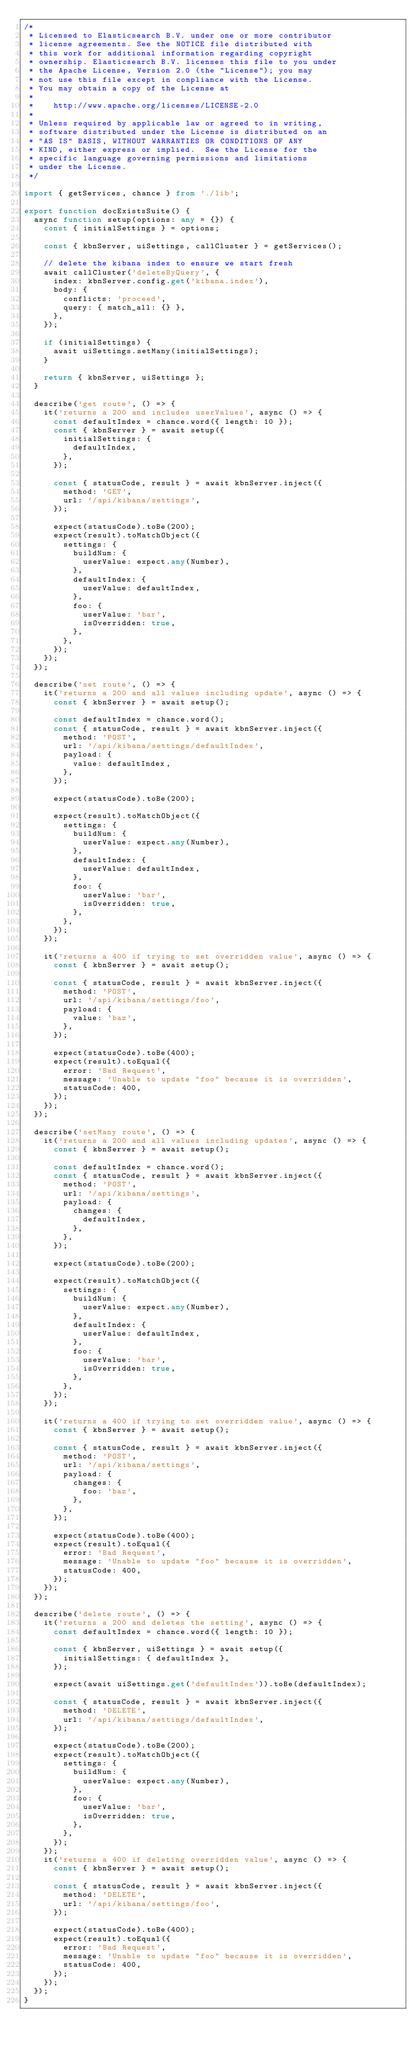Convert code to text. <code><loc_0><loc_0><loc_500><loc_500><_TypeScript_>/*
 * Licensed to Elasticsearch B.V. under one or more contributor
 * license agreements. See the NOTICE file distributed with
 * this work for additional information regarding copyright
 * ownership. Elasticsearch B.V. licenses this file to you under
 * the Apache License, Version 2.0 (the "License"); you may
 * not use this file except in compliance with the License.
 * You may obtain a copy of the License at
 *
 *    http://www.apache.org/licenses/LICENSE-2.0
 *
 * Unless required by applicable law or agreed to in writing,
 * software distributed under the License is distributed on an
 * "AS IS" BASIS, WITHOUT WARRANTIES OR CONDITIONS OF ANY
 * KIND, either express or implied.  See the License for the
 * specific language governing permissions and limitations
 * under the License.
 */

import { getServices, chance } from './lib';

export function docExistsSuite() {
  async function setup(options: any = {}) {
    const { initialSettings } = options;

    const { kbnServer, uiSettings, callCluster } = getServices();

    // delete the kibana index to ensure we start fresh
    await callCluster('deleteByQuery', {
      index: kbnServer.config.get('kibana.index'),
      body: {
        conflicts: 'proceed',
        query: { match_all: {} },
      },
    });

    if (initialSettings) {
      await uiSettings.setMany(initialSettings);
    }

    return { kbnServer, uiSettings };
  }

  describe('get route', () => {
    it('returns a 200 and includes userValues', async () => {
      const defaultIndex = chance.word({ length: 10 });
      const { kbnServer } = await setup({
        initialSettings: {
          defaultIndex,
        },
      });

      const { statusCode, result } = await kbnServer.inject({
        method: 'GET',
        url: '/api/kibana/settings',
      });

      expect(statusCode).toBe(200);
      expect(result).toMatchObject({
        settings: {
          buildNum: {
            userValue: expect.any(Number),
          },
          defaultIndex: {
            userValue: defaultIndex,
          },
          foo: {
            userValue: 'bar',
            isOverridden: true,
          },
        },
      });
    });
  });

  describe('set route', () => {
    it('returns a 200 and all values including update', async () => {
      const { kbnServer } = await setup();

      const defaultIndex = chance.word();
      const { statusCode, result } = await kbnServer.inject({
        method: 'POST',
        url: '/api/kibana/settings/defaultIndex',
        payload: {
          value: defaultIndex,
        },
      });

      expect(statusCode).toBe(200);

      expect(result).toMatchObject({
        settings: {
          buildNum: {
            userValue: expect.any(Number),
          },
          defaultIndex: {
            userValue: defaultIndex,
          },
          foo: {
            userValue: 'bar',
            isOverridden: true,
          },
        },
      });
    });

    it('returns a 400 if trying to set overridden value', async () => {
      const { kbnServer } = await setup();

      const { statusCode, result } = await kbnServer.inject({
        method: 'POST',
        url: '/api/kibana/settings/foo',
        payload: {
          value: 'baz',
        },
      });

      expect(statusCode).toBe(400);
      expect(result).toEqual({
        error: 'Bad Request',
        message: 'Unable to update "foo" because it is overridden',
        statusCode: 400,
      });
    });
  });

  describe('setMany route', () => {
    it('returns a 200 and all values including updates', async () => {
      const { kbnServer } = await setup();

      const defaultIndex = chance.word();
      const { statusCode, result } = await kbnServer.inject({
        method: 'POST',
        url: '/api/kibana/settings',
        payload: {
          changes: {
            defaultIndex,
          },
        },
      });

      expect(statusCode).toBe(200);

      expect(result).toMatchObject({
        settings: {
          buildNum: {
            userValue: expect.any(Number),
          },
          defaultIndex: {
            userValue: defaultIndex,
          },
          foo: {
            userValue: 'bar',
            isOverridden: true,
          },
        },
      });
    });

    it('returns a 400 if trying to set overridden value', async () => {
      const { kbnServer } = await setup();

      const { statusCode, result } = await kbnServer.inject({
        method: 'POST',
        url: '/api/kibana/settings',
        payload: {
          changes: {
            foo: 'baz',
          },
        },
      });

      expect(statusCode).toBe(400);
      expect(result).toEqual({
        error: 'Bad Request',
        message: 'Unable to update "foo" because it is overridden',
        statusCode: 400,
      });
    });
  });

  describe('delete route', () => {
    it('returns a 200 and deletes the setting', async () => {
      const defaultIndex = chance.word({ length: 10 });

      const { kbnServer, uiSettings } = await setup({
        initialSettings: { defaultIndex },
      });

      expect(await uiSettings.get('defaultIndex')).toBe(defaultIndex);

      const { statusCode, result } = await kbnServer.inject({
        method: 'DELETE',
        url: '/api/kibana/settings/defaultIndex',
      });

      expect(statusCode).toBe(200);
      expect(result).toMatchObject({
        settings: {
          buildNum: {
            userValue: expect.any(Number),
          },
          foo: {
            userValue: 'bar',
            isOverridden: true,
          },
        },
      });
    });
    it('returns a 400 if deleting overridden value', async () => {
      const { kbnServer } = await setup();

      const { statusCode, result } = await kbnServer.inject({
        method: 'DELETE',
        url: '/api/kibana/settings/foo',
      });

      expect(statusCode).toBe(400);
      expect(result).toEqual({
        error: 'Bad Request',
        message: 'Unable to update "foo" because it is overridden',
        statusCode: 400,
      });
    });
  });
}
</code> 